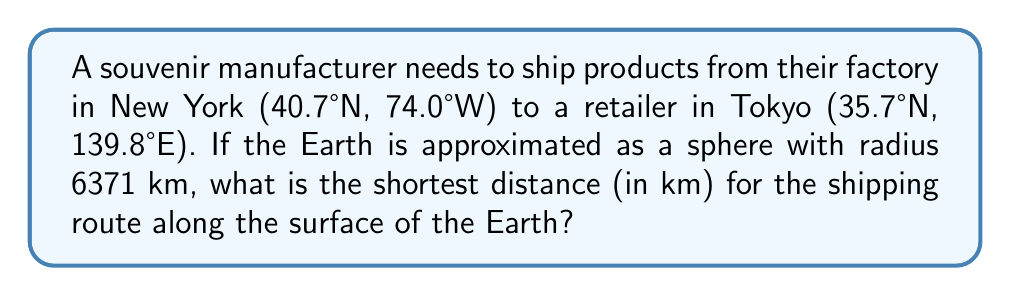Can you answer this question? To find the shortest distance between two points on a sphere, we need to calculate the great circle distance. We'll use the haversine formula:

1) Convert latitudes and longitudes to radians:
   $\phi_1 = 40.7° \times \frac{\pi}{180} = 0.7101$ rad
   $\lambda_1 = -74.0° \times \frac{\pi}{180} = -1.2915$ rad
   $\phi_2 = 35.7° \times \frac{\pi}{180} = 0.6230$ rad
   $\lambda_2 = 139.8° \times \frac{\pi}{180} = 2.4400$ rad

2) Calculate the central angle $\Delta\sigma$ using the haversine formula:
   $$\Delta\sigma = 2 \arcsin\left(\sqrt{\sin^2\left(\frac{\phi_2-\phi_1}{2}\right) + \cos\phi_1\cos\phi_2\sin^2\left(\frac{\lambda_2-\lambda_1}{2}\right)}\right)$$

3) Substitute the values:
   $$\Delta\sigma = 2 \arcsin\left(\sqrt{\sin^2\left(\frac{0.6230-0.7101}{2}\right) + \cos(0.7101)\cos(0.6230)\sin^2\left(\frac{2.4400-(-1.2915)}{2}\right)}\right)$$

4) Calculate:
   $\Delta\sigma = 1.9635$ rad

5) The distance $d$ is the product of the Earth's radius $R$ and the central angle:
   $d = R \times \Delta\sigma = 6371 \times 1.9635 = 12509.3$ km

Therefore, the shortest shipping route distance is approximately 12509 km.
Answer: 12509 km 